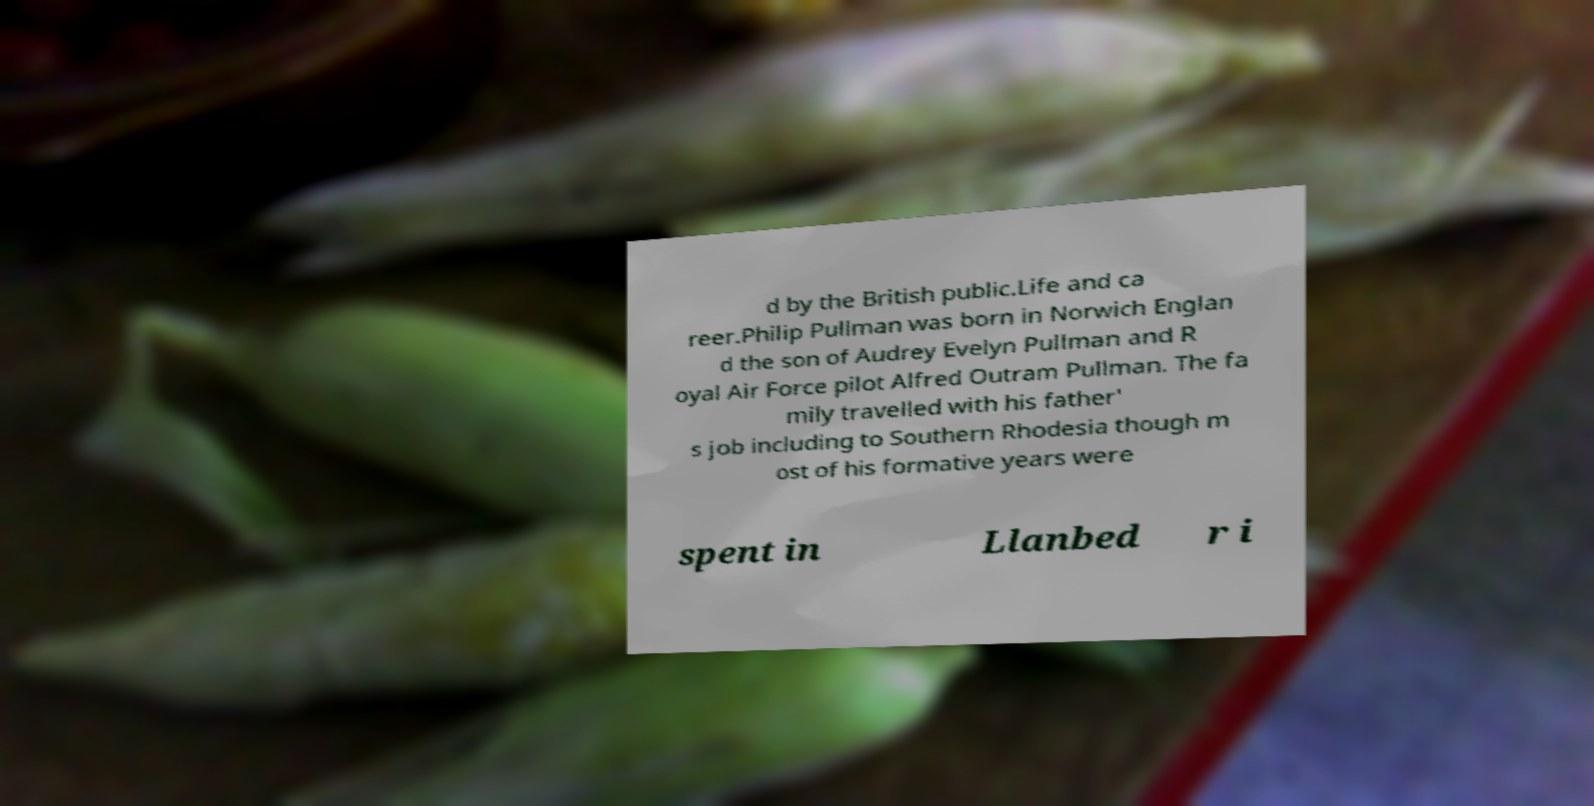I need the written content from this picture converted into text. Can you do that? d by the British public.Life and ca reer.Philip Pullman was born in Norwich Englan d the son of Audrey Evelyn Pullman and R oyal Air Force pilot Alfred Outram Pullman. The fa mily travelled with his father' s job including to Southern Rhodesia though m ost of his formative years were spent in Llanbed r i 